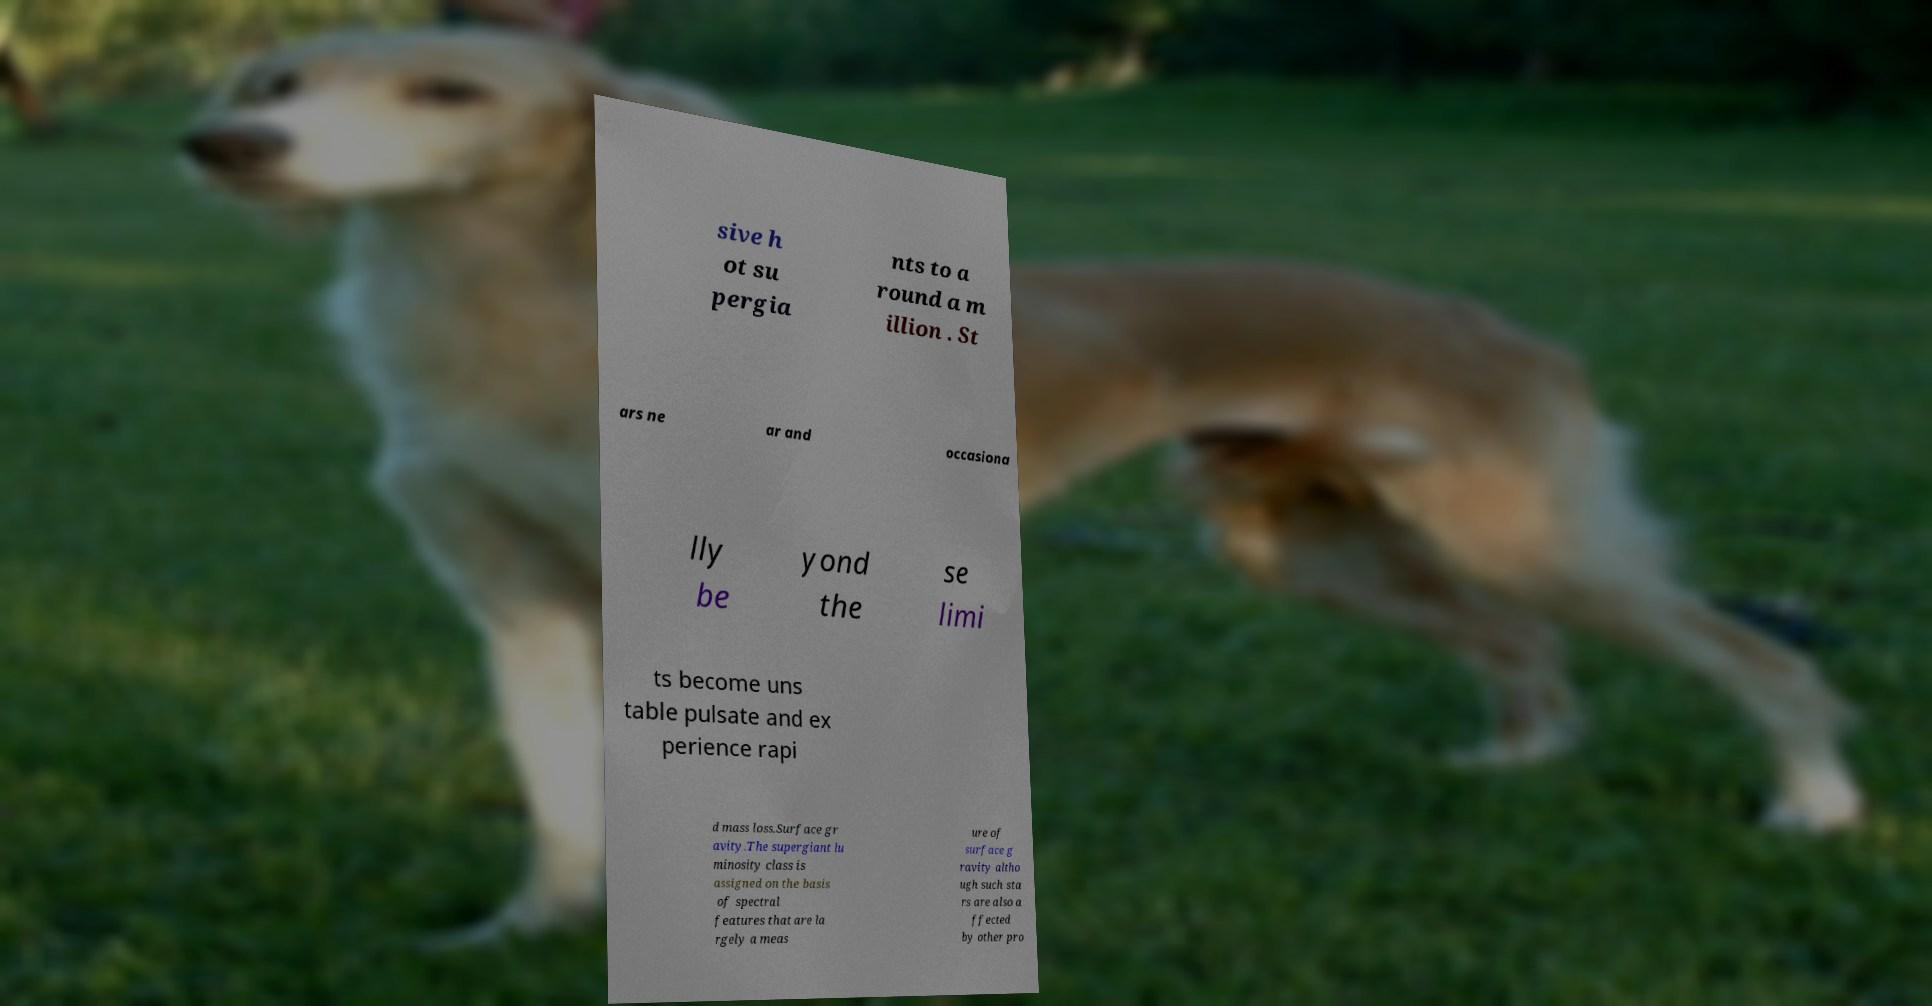Please identify and transcribe the text found in this image. sive h ot su pergia nts to a round a m illion . St ars ne ar and occasiona lly be yond the se limi ts become uns table pulsate and ex perience rapi d mass loss.Surface gr avity.The supergiant lu minosity class is assigned on the basis of spectral features that are la rgely a meas ure of surface g ravity altho ugh such sta rs are also a ffected by other pro 